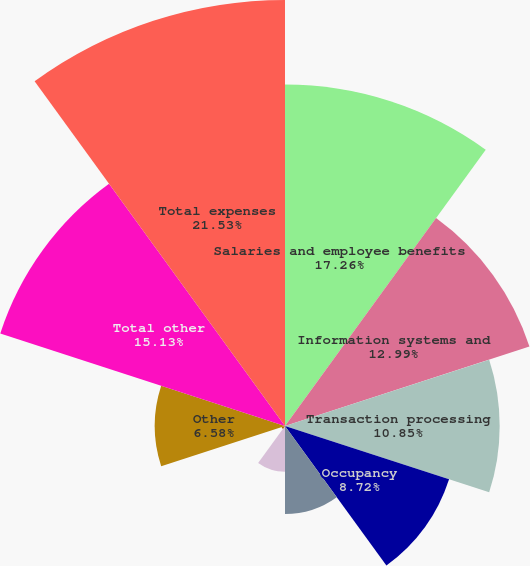<chart> <loc_0><loc_0><loc_500><loc_500><pie_chart><fcel>Salaries and employee benefits<fcel>Information systems and<fcel>Transaction processing<fcel>Occupancy<fcel>Professional services<fcel>Amortization of other<fcel>Securities processing<fcel>Other<fcel>Total other<fcel>Total expenses<nl><fcel>17.26%<fcel>12.99%<fcel>10.85%<fcel>8.72%<fcel>4.45%<fcel>2.31%<fcel>0.18%<fcel>6.58%<fcel>15.13%<fcel>21.53%<nl></chart> 